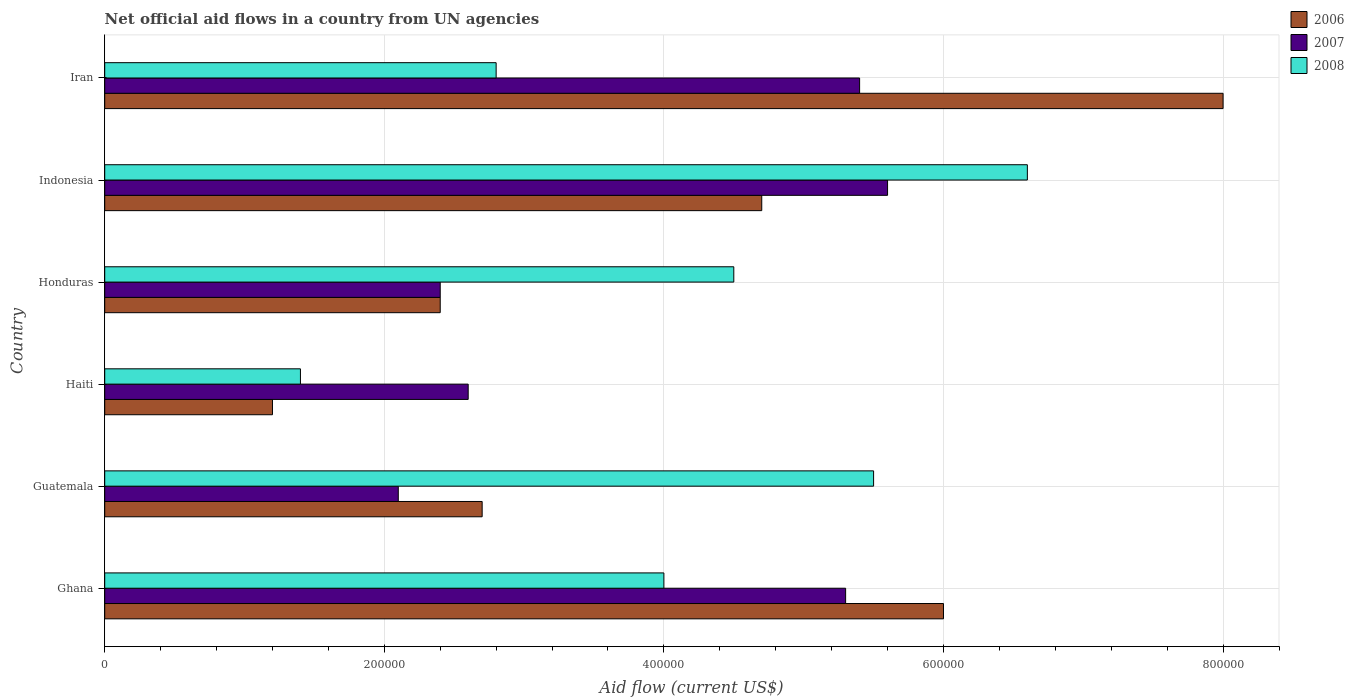How many different coloured bars are there?
Keep it short and to the point. 3. How many groups of bars are there?
Offer a terse response. 6. How many bars are there on the 4th tick from the top?
Provide a succinct answer. 3. What is the label of the 2nd group of bars from the top?
Your response must be concise. Indonesia. What is the net official aid flow in 2008 in Ghana?
Offer a terse response. 4.00e+05. Across all countries, what is the minimum net official aid flow in 2006?
Provide a succinct answer. 1.20e+05. In which country was the net official aid flow in 2006 maximum?
Give a very brief answer. Iran. In which country was the net official aid flow in 2006 minimum?
Your answer should be compact. Haiti. What is the total net official aid flow in 2007 in the graph?
Ensure brevity in your answer.  2.34e+06. What is the difference between the net official aid flow in 2007 in Guatemala and that in Iran?
Give a very brief answer. -3.30e+05. What is the difference between the net official aid flow in 2008 in Guatemala and the net official aid flow in 2007 in Haiti?
Offer a terse response. 2.90e+05. What is the average net official aid flow in 2008 per country?
Give a very brief answer. 4.13e+05. In how many countries, is the net official aid flow in 2007 greater than 560000 US$?
Provide a succinct answer. 0. What is the ratio of the net official aid flow in 2007 in Ghana to that in Honduras?
Offer a terse response. 2.21. What is the difference between the highest and the second highest net official aid flow in 2007?
Offer a terse response. 2.00e+04. In how many countries, is the net official aid flow in 2007 greater than the average net official aid flow in 2007 taken over all countries?
Provide a short and direct response. 3. Is the sum of the net official aid flow in 2007 in Ghana and Indonesia greater than the maximum net official aid flow in 2008 across all countries?
Offer a very short reply. Yes. What does the 1st bar from the top in Haiti represents?
Offer a terse response. 2008. What does the 1st bar from the bottom in Haiti represents?
Provide a short and direct response. 2006. Are all the bars in the graph horizontal?
Offer a very short reply. Yes. What is the difference between two consecutive major ticks on the X-axis?
Your answer should be compact. 2.00e+05. Are the values on the major ticks of X-axis written in scientific E-notation?
Ensure brevity in your answer.  No. Does the graph contain any zero values?
Provide a short and direct response. No. What is the title of the graph?
Provide a succinct answer. Net official aid flows in a country from UN agencies. Does "1981" appear as one of the legend labels in the graph?
Keep it short and to the point. No. What is the label or title of the Y-axis?
Keep it short and to the point. Country. What is the Aid flow (current US$) of 2007 in Ghana?
Give a very brief answer. 5.30e+05. What is the Aid flow (current US$) in 2006 in Guatemala?
Keep it short and to the point. 2.70e+05. What is the Aid flow (current US$) of 2008 in Guatemala?
Offer a terse response. 5.50e+05. What is the Aid flow (current US$) in 2006 in Haiti?
Provide a succinct answer. 1.20e+05. What is the Aid flow (current US$) of 2007 in Haiti?
Make the answer very short. 2.60e+05. What is the Aid flow (current US$) in 2007 in Honduras?
Provide a short and direct response. 2.40e+05. What is the Aid flow (current US$) in 2007 in Indonesia?
Give a very brief answer. 5.60e+05. What is the Aid flow (current US$) in 2006 in Iran?
Provide a short and direct response. 8.00e+05. What is the Aid flow (current US$) of 2007 in Iran?
Your answer should be compact. 5.40e+05. Across all countries, what is the maximum Aid flow (current US$) of 2007?
Your answer should be compact. 5.60e+05. Across all countries, what is the minimum Aid flow (current US$) in 2006?
Give a very brief answer. 1.20e+05. What is the total Aid flow (current US$) in 2006 in the graph?
Your response must be concise. 2.50e+06. What is the total Aid flow (current US$) in 2007 in the graph?
Your answer should be very brief. 2.34e+06. What is the total Aid flow (current US$) of 2008 in the graph?
Your answer should be very brief. 2.48e+06. What is the difference between the Aid flow (current US$) in 2008 in Ghana and that in Guatemala?
Make the answer very short. -1.50e+05. What is the difference between the Aid flow (current US$) of 2006 in Ghana and that in Haiti?
Make the answer very short. 4.80e+05. What is the difference between the Aid flow (current US$) of 2008 in Ghana and that in Honduras?
Your response must be concise. -5.00e+04. What is the difference between the Aid flow (current US$) in 2008 in Guatemala and that in Haiti?
Offer a very short reply. 4.10e+05. What is the difference between the Aid flow (current US$) in 2006 in Guatemala and that in Honduras?
Give a very brief answer. 3.00e+04. What is the difference between the Aid flow (current US$) in 2006 in Guatemala and that in Indonesia?
Offer a terse response. -2.00e+05. What is the difference between the Aid flow (current US$) in 2007 in Guatemala and that in Indonesia?
Provide a short and direct response. -3.50e+05. What is the difference between the Aid flow (current US$) of 2008 in Guatemala and that in Indonesia?
Provide a succinct answer. -1.10e+05. What is the difference between the Aid flow (current US$) in 2006 in Guatemala and that in Iran?
Ensure brevity in your answer.  -5.30e+05. What is the difference between the Aid flow (current US$) in 2007 in Guatemala and that in Iran?
Offer a terse response. -3.30e+05. What is the difference between the Aid flow (current US$) of 2006 in Haiti and that in Honduras?
Provide a succinct answer. -1.20e+05. What is the difference between the Aid flow (current US$) of 2007 in Haiti and that in Honduras?
Provide a succinct answer. 2.00e+04. What is the difference between the Aid flow (current US$) in 2008 in Haiti and that in Honduras?
Your answer should be compact. -3.10e+05. What is the difference between the Aid flow (current US$) of 2006 in Haiti and that in Indonesia?
Give a very brief answer. -3.50e+05. What is the difference between the Aid flow (current US$) of 2008 in Haiti and that in Indonesia?
Offer a very short reply. -5.20e+05. What is the difference between the Aid flow (current US$) of 2006 in Haiti and that in Iran?
Make the answer very short. -6.80e+05. What is the difference between the Aid flow (current US$) of 2007 in Haiti and that in Iran?
Offer a very short reply. -2.80e+05. What is the difference between the Aid flow (current US$) in 2008 in Haiti and that in Iran?
Your response must be concise. -1.40e+05. What is the difference between the Aid flow (current US$) in 2007 in Honduras and that in Indonesia?
Make the answer very short. -3.20e+05. What is the difference between the Aid flow (current US$) of 2006 in Honduras and that in Iran?
Make the answer very short. -5.60e+05. What is the difference between the Aid flow (current US$) in 2007 in Honduras and that in Iran?
Keep it short and to the point. -3.00e+05. What is the difference between the Aid flow (current US$) of 2008 in Honduras and that in Iran?
Your response must be concise. 1.70e+05. What is the difference between the Aid flow (current US$) in 2006 in Indonesia and that in Iran?
Offer a terse response. -3.30e+05. What is the difference between the Aid flow (current US$) in 2008 in Indonesia and that in Iran?
Ensure brevity in your answer.  3.80e+05. What is the difference between the Aid flow (current US$) in 2006 in Ghana and the Aid flow (current US$) in 2007 in Guatemala?
Make the answer very short. 3.90e+05. What is the difference between the Aid flow (current US$) of 2006 in Ghana and the Aid flow (current US$) of 2008 in Guatemala?
Offer a terse response. 5.00e+04. What is the difference between the Aid flow (current US$) of 2006 in Ghana and the Aid flow (current US$) of 2007 in Haiti?
Offer a terse response. 3.40e+05. What is the difference between the Aid flow (current US$) in 2006 in Ghana and the Aid flow (current US$) in 2007 in Honduras?
Make the answer very short. 3.60e+05. What is the difference between the Aid flow (current US$) of 2006 in Ghana and the Aid flow (current US$) of 2008 in Indonesia?
Offer a very short reply. -6.00e+04. What is the difference between the Aid flow (current US$) of 2006 in Guatemala and the Aid flow (current US$) of 2007 in Haiti?
Offer a terse response. 10000. What is the difference between the Aid flow (current US$) of 2006 in Guatemala and the Aid flow (current US$) of 2007 in Honduras?
Provide a short and direct response. 3.00e+04. What is the difference between the Aid flow (current US$) in 2006 in Guatemala and the Aid flow (current US$) in 2008 in Honduras?
Give a very brief answer. -1.80e+05. What is the difference between the Aid flow (current US$) of 2007 in Guatemala and the Aid flow (current US$) of 2008 in Honduras?
Make the answer very short. -2.40e+05. What is the difference between the Aid flow (current US$) in 2006 in Guatemala and the Aid flow (current US$) in 2007 in Indonesia?
Your response must be concise. -2.90e+05. What is the difference between the Aid flow (current US$) of 2006 in Guatemala and the Aid flow (current US$) of 2008 in Indonesia?
Your answer should be very brief. -3.90e+05. What is the difference between the Aid flow (current US$) in 2007 in Guatemala and the Aid flow (current US$) in 2008 in Indonesia?
Make the answer very short. -4.50e+05. What is the difference between the Aid flow (current US$) of 2006 in Guatemala and the Aid flow (current US$) of 2007 in Iran?
Make the answer very short. -2.70e+05. What is the difference between the Aid flow (current US$) in 2007 in Guatemala and the Aid flow (current US$) in 2008 in Iran?
Give a very brief answer. -7.00e+04. What is the difference between the Aid flow (current US$) in 2006 in Haiti and the Aid flow (current US$) in 2007 in Honduras?
Provide a succinct answer. -1.20e+05. What is the difference between the Aid flow (current US$) of 2006 in Haiti and the Aid flow (current US$) of 2008 in Honduras?
Your response must be concise. -3.30e+05. What is the difference between the Aid flow (current US$) of 2007 in Haiti and the Aid flow (current US$) of 2008 in Honduras?
Provide a short and direct response. -1.90e+05. What is the difference between the Aid flow (current US$) in 2006 in Haiti and the Aid flow (current US$) in 2007 in Indonesia?
Offer a very short reply. -4.40e+05. What is the difference between the Aid flow (current US$) of 2006 in Haiti and the Aid flow (current US$) of 2008 in Indonesia?
Give a very brief answer. -5.40e+05. What is the difference between the Aid flow (current US$) of 2007 in Haiti and the Aid flow (current US$) of 2008 in Indonesia?
Your response must be concise. -4.00e+05. What is the difference between the Aid flow (current US$) of 2006 in Haiti and the Aid flow (current US$) of 2007 in Iran?
Provide a succinct answer. -4.20e+05. What is the difference between the Aid flow (current US$) in 2006 in Honduras and the Aid flow (current US$) in 2007 in Indonesia?
Provide a short and direct response. -3.20e+05. What is the difference between the Aid flow (current US$) in 2006 in Honduras and the Aid flow (current US$) in 2008 in Indonesia?
Keep it short and to the point. -4.20e+05. What is the difference between the Aid flow (current US$) of 2007 in Honduras and the Aid flow (current US$) of 2008 in Indonesia?
Offer a very short reply. -4.20e+05. What is the difference between the Aid flow (current US$) of 2006 in Indonesia and the Aid flow (current US$) of 2008 in Iran?
Give a very brief answer. 1.90e+05. What is the average Aid flow (current US$) of 2006 per country?
Keep it short and to the point. 4.17e+05. What is the average Aid flow (current US$) in 2007 per country?
Provide a short and direct response. 3.90e+05. What is the average Aid flow (current US$) of 2008 per country?
Offer a very short reply. 4.13e+05. What is the difference between the Aid flow (current US$) of 2006 and Aid flow (current US$) of 2007 in Ghana?
Your answer should be compact. 7.00e+04. What is the difference between the Aid flow (current US$) in 2006 and Aid flow (current US$) in 2008 in Ghana?
Offer a very short reply. 2.00e+05. What is the difference between the Aid flow (current US$) in 2007 and Aid flow (current US$) in 2008 in Ghana?
Provide a succinct answer. 1.30e+05. What is the difference between the Aid flow (current US$) of 2006 and Aid flow (current US$) of 2008 in Guatemala?
Ensure brevity in your answer.  -2.80e+05. What is the difference between the Aid flow (current US$) of 2007 and Aid flow (current US$) of 2008 in Guatemala?
Offer a terse response. -3.40e+05. What is the difference between the Aid flow (current US$) of 2006 and Aid flow (current US$) of 2007 in Haiti?
Your response must be concise. -1.40e+05. What is the difference between the Aid flow (current US$) of 2006 and Aid flow (current US$) of 2008 in Haiti?
Your answer should be very brief. -2.00e+04. What is the difference between the Aid flow (current US$) of 2006 and Aid flow (current US$) of 2007 in Honduras?
Keep it short and to the point. 0. What is the difference between the Aid flow (current US$) of 2006 and Aid flow (current US$) of 2007 in Indonesia?
Make the answer very short. -9.00e+04. What is the difference between the Aid flow (current US$) in 2007 and Aid flow (current US$) in 2008 in Indonesia?
Keep it short and to the point. -1.00e+05. What is the difference between the Aid flow (current US$) in 2006 and Aid flow (current US$) in 2008 in Iran?
Provide a succinct answer. 5.20e+05. What is the difference between the Aid flow (current US$) in 2007 and Aid flow (current US$) in 2008 in Iran?
Provide a short and direct response. 2.60e+05. What is the ratio of the Aid flow (current US$) in 2006 in Ghana to that in Guatemala?
Provide a succinct answer. 2.22. What is the ratio of the Aid flow (current US$) of 2007 in Ghana to that in Guatemala?
Keep it short and to the point. 2.52. What is the ratio of the Aid flow (current US$) of 2008 in Ghana to that in Guatemala?
Give a very brief answer. 0.73. What is the ratio of the Aid flow (current US$) of 2006 in Ghana to that in Haiti?
Provide a succinct answer. 5. What is the ratio of the Aid flow (current US$) of 2007 in Ghana to that in Haiti?
Your response must be concise. 2.04. What is the ratio of the Aid flow (current US$) of 2008 in Ghana to that in Haiti?
Keep it short and to the point. 2.86. What is the ratio of the Aid flow (current US$) in 2007 in Ghana to that in Honduras?
Make the answer very short. 2.21. What is the ratio of the Aid flow (current US$) in 2008 in Ghana to that in Honduras?
Your response must be concise. 0.89. What is the ratio of the Aid flow (current US$) of 2006 in Ghana to that in Indonesia?
Your answer should be very brief. 1.28. What is the ratio of the Aid flow (current US$) of 2007 in Ghana to that in Indonesia?
Your answer should be very brief. 0.95. What is the ratio of the Aid flow (current US$) of 2008 in Ghana to that in Indonesia?
Keep it short and to the point. 0.61. What is the ratio of the Aid flow (current US$) in 2006 in Ghana to that in Iran?
Provide a short and direct response. 0.75. What is the ratio of the Aid flow (current US$) in 2007 in Ghana to that in Iran?
Ensure brevity in your answer.  0.98. What is the ratio of the Aid flow (current US$) of 2008 in Ghana to that in Iran?
Your answer should be compact. 1.43. What is the ratio of the Aid flow (current US$) in 2006 in Guatemala to that in Haiti?
Offer a very short reply. 2.25. What is the ratio of the Aid flow (current US$) in 2007 in Guatemala to that in Haiti?
Your answer should be very brief. 0.81. What is the ratio of the Aid flow (current US$) of 2008 in Guatemala to that in Haiti?
Provide a short and direct response. 3.93. What is the ratio of the Aid flow (current US$) in 2008 in Guatemala to that in Honduras?
Your response must be concise. 1.22. What is the ratio of the Aid flow (current US$) of 2006 in Guatemala to that in Indonesia?
Provide a succinct answer. 0.57. What is the ratio of the Aid flow (current US$) in 2006 in Guatemala to that in Iran?
Your answer should be compact. 0.34. What is the ratio of the Aid flow (current US$) in 2007 in Guatemala to that in Iran?
Your response must be concise. 0.39. What is the ratio of the Aid flow (current US$) in 2008 in Guatemala to that in Iran?
Keep it short and to the point. 1.96. What is the ratio of the Aid flow (current US$) in 2008 in Haiti to that in Honduras?
Offer a very short reply. 0.31. What is the ratio of the Aid flow (current US$) of 2006 in Haiti to that in Indonesia?
Give a very brief answer. 0.26. What is the ratio of the Aid flow (current US$) in 2007 in Haiti to that in Indonesia?
Your answer should be compact. 0.46. What is the ratio of the Aid flow (current US$) of 2008 in Haiti to that in Indonesia?
Ensure brevity in your answer.  0.21. What is the ratio of the Aid flow (current US$) in 2006 in Haiti to that in Iran?
Your response must be concise. 0.15. What is the ratio of the Aid flow (current US$) of 2007 in Haiti to that in Iran?
Provide a short and direct response. 0.48. What is the ratio of the Aid flow (current US$) in 2008 in Haiti to that in Iran?
Give a very brief answer. 0.5. What is the ratio of the Aid flow (current US$) in 2006 in Honduras to that in Indonesia?
Offer a very short reply. 0.51. What is the ratio of the Aid flow (current US$) of 2007 in Honduras to that in Indonesia?
Provide a short and direct response. 0.43. What is the ratio of the Aid flow (current US$) in 2008 in Honduras to that in Indonesia?
Your response must be concise. 0.68. What is the ratio of the Aid flow (current US$) in 2007 in Honduras to that in Iran?
Offer a very short reply. 0.44. What is the ratio of the Aid flow (current US$) of 2008 in Honduras to that in Iran?
Ensure brevity in your answer.  1.61. What is the ratio of the Aid flow (current US$) of 2006 in Indonesia to that in Iran?
Keep it short and to the point. 0.59. What is the ratio of the Aid flow (current US$) in 2007 in Indonesia to that in Iran?
Offer a very short reply. 1.04. What is the ratio of the Aid flow (current US$) of 2008 in Indonesia to that in Iran?
Keep it short and to the point. 2.36. What is the difference between the highest and the second highest Aid flow (current US$) in 2006?
Provide a short and direct response. 2.00e+05. What is the difference between the highest and the lowest Aid flow (current US$) of 2006?
Make the answer very short. 6.80e+05. What is the difference between the highest and the lowest Aid flow (current US$) in 2007?
Your response must be concise. 3.50e+05. What is the difference between the highest and the lowest Aid flow (current US$) in 2008?
Give a very brief answer. 5.20e+05. 